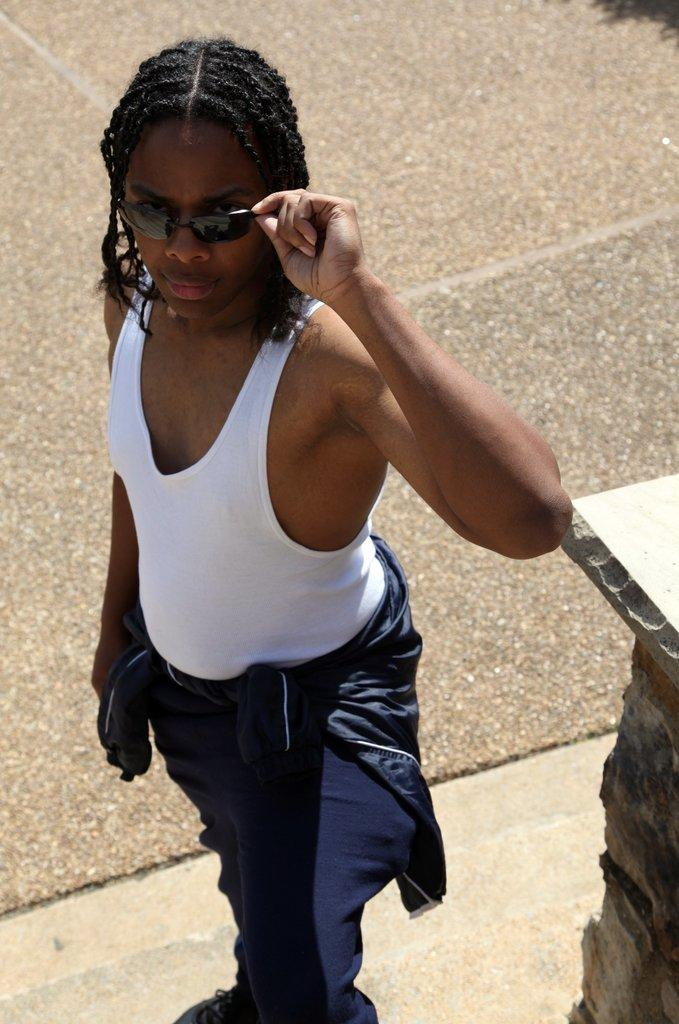What is the main subject of the image? There is a person standing in the image. What is the person wearing that is visible in the image? The person is wearing shades. What type of surface is at the bottom of the image? There is a road at the bottom of the image. What structure can be seen to the right of the image? There is a pillar to the right of the image. What direction is the person facing in the image? The provided facts do not indicate the direction the person is facing. Can you tell me the plot of the story being told in the image? The image does not depict a story or plot; it is a static scene with a person standing, wearing shades, and a road and pillar in the background. 